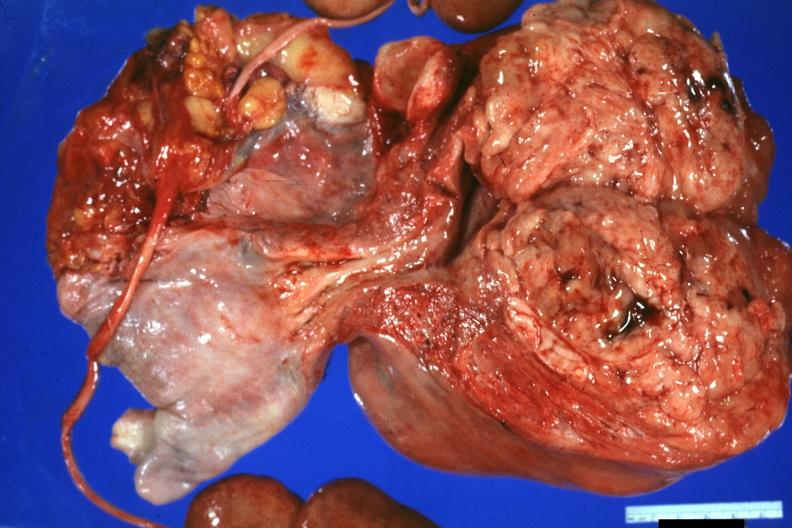does this image show nicely shown large neoplasm with fish flesh cerebriform appearance?
Answer the question using a single word or phrase. Yes 